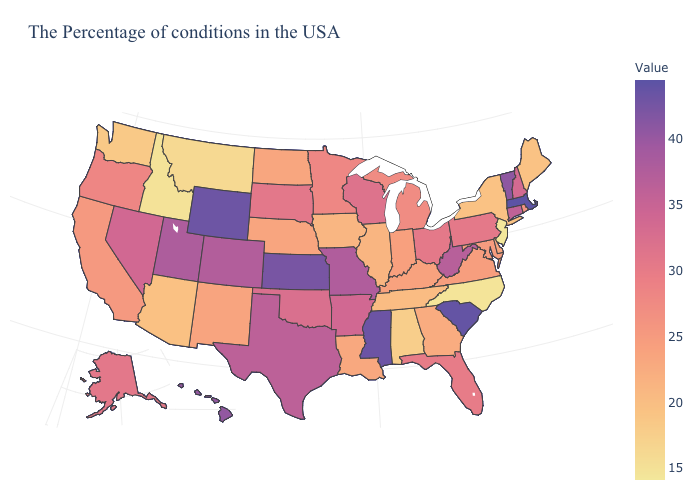Among the states that border Maine , which have the highest value?
Answer briefly. New Hampshire. Among the states that border Louisiana , does Arkansas have the lowest value?
Answer briefly. Yes. Which states hav the highest value in the MidWest?
Write a very short answer. Kansas. Does Idaho have the highest value in the West?
Be succinct. No. Is the legend a continuous bar?
Give a very brief answer. Yes. Which states have the lowest value in the USA?
Keep it brief. New Jersey. 